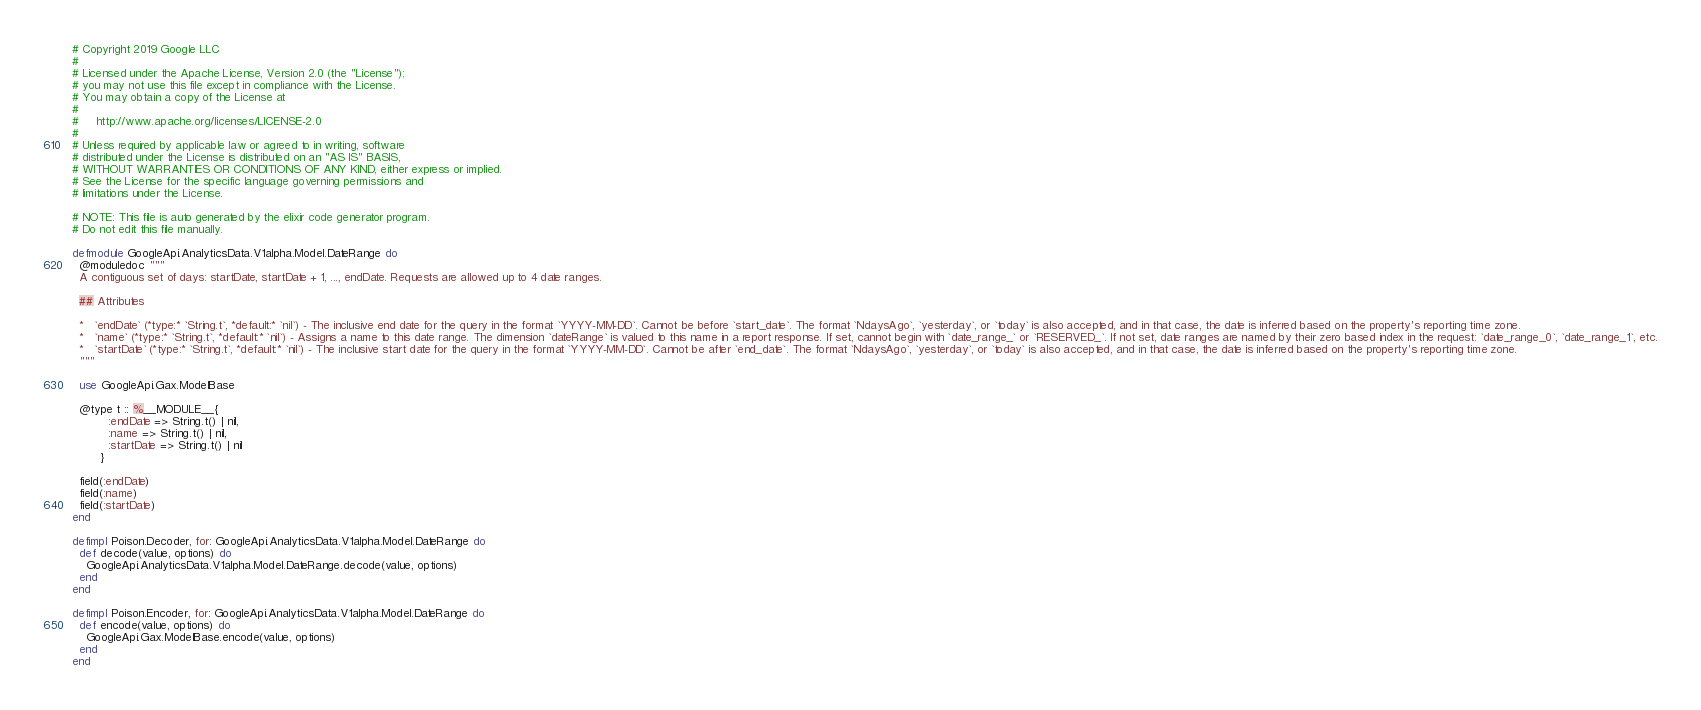Convert code to text. <code><loc_0><loc_0><loc_500><loc_500><_Elixir_># Copyright 2019 Google LLC
#
# Licensed under the Apache License, Version 2.0 (the "License");
# you may not use this file except in compliance with the License.
# You may obtain a copy of the License at
#
#     http://www.apache.org/licenses/LICENSE-2.0
#
# Unless required by applicable law or agreed to in writing, software
# distributed under the License is distributed on an "AS IS" BASIS,
# WITHOUT WARRANTIES OR CONDITIONS OF ANY KIND, either express or implied.
# See the License for the specific language governing permissions and
# limitations under the License.

# NOTE: This file is auto generated by the elixir code generator program.
# Do not edit this file manually.

defmodule GoogleApi.AnalyticsData.V1alpha.Model.DateRange do
  @moduledoc """
  A contiguous set of days: startDate, startDate + 1, ..., endDate. Requests are allowed up to 4 date ranges.

  ## Attributes

  *   `endDate` (*type:* `String.t`, *default:* `nil`) - The inclusive end date for the query in the format `YYYY-MM-DD`. Cannot be before `start_date`. The format `NdaysAgo`, `yesterday`, or `today` is also accepted, and in that case, the date is inferred based on the property's reporting time zone.
  *   `name` (*type:* `String.t`, *default:* `nil`) - Assigns a name to this date range. The dimension `dateRange` is valued to this name in a report response. If set, cannot begin with `date_range_` or `RESERVED_`. If not set, date ranges are named by their zero based index in the request: `date_range_0`, `date_range_1`, etc.
  *   `startDate` (*type:* `String.t`, *default:* `nil`) - The inclusive start date for the query in the format `YYYY-MM-DD`. Cannot be after `end_date`. The format `NdaysAgo`, `yesterday`, or `today` is also accepted, and in that case, the date is inferred based on the property's reporting time zone.
  """

  use GoogleApi.Gax.ModelBase

  @type t :: %__MODULE__{
          :endDate => String.t() | nil,
          :name => String.t() | nil,
          :startDate => String.t() | nil
        }

  field(:endDate)
  field(:name)
  field(:startDate)
end

defimpl Poison.Decoder, for: GoogleApi.AnalyticsData.V1alpha.Model.DateRange do
  def decode(value, options) do
    GoogleApi.AnalyticsData.V1alpha.Model.DateRange.decode(value, options)
  end
end

defimpl Poison.Encoder, for: GoogleApi.AnalyticsData.V1alpha.Model.DateRange do
  def encode(value, options) do
    GoogleApi.Gax.ModelBase.encode(value, options)
  end
end
</code> 